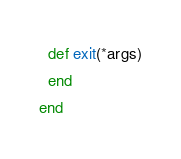Convert code to text. <code><loc_0><loc_0><loc_500><loc_500><_Crystal_>
  def exit(*args)
  end
end
</code> 